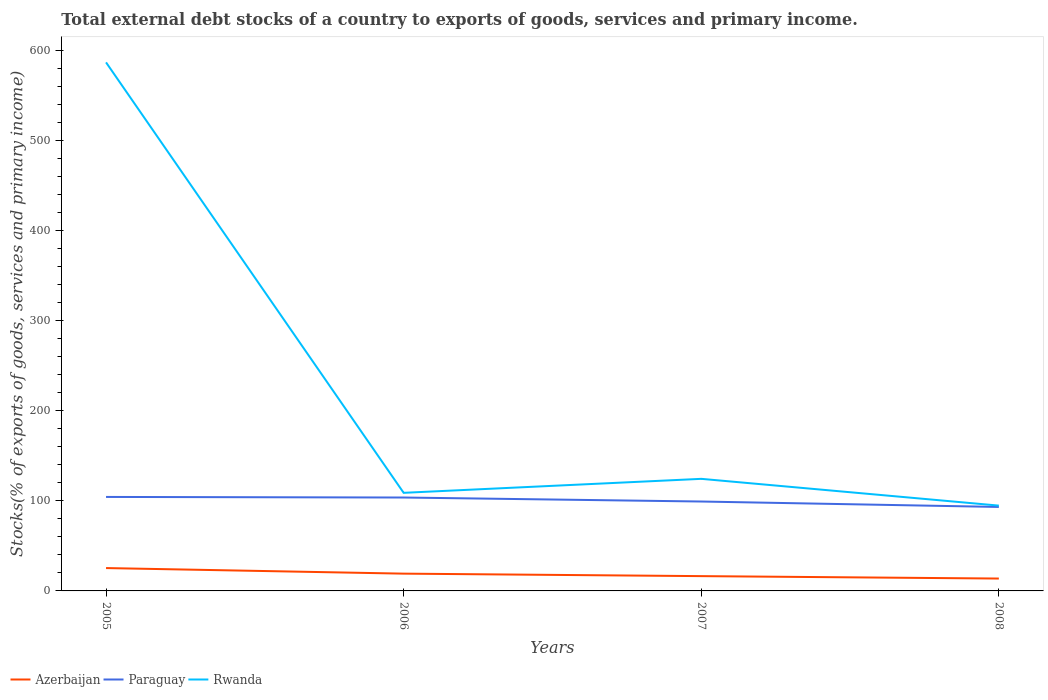Across all years, what is the maximum total debt stocks in Paraguay?
Your response must be concise. 93.31. What is the total total debt stocks in Rwanda in the graph?
Make the answer very short. -15.54. What is the difference between the highest and the second highest total debt stocks in Azerbaijan?
Provide a short and direct response. 11.65. What is the difference between the highest and the lowest total debt stocks in Rwanda?
Offer a terse response. 1. How many lines are there?
Provide a succinct answer. 3. How many years are there in the graph?
Your answer should be compact. 4. Are the values on the major ticks of Y-axis written in scientific E-notation?
Your answer should be compact. No. Does the graph contain any zero values?
Your answer should be very brief. No. Where does the legend appear in the graph?
Provide a succinct answer. Bottom left. What is the title of the graph?
Ensure brevity in your answer.  Total external debt stocks of a country to exports of goods, services and primary income. Does "Mexico" appear as one of the legend labels in the graph?
Give a very brief answer. No. What is the label or title of the X-axis?
Provide a short and direct response. Years. What is the label or title of the Y-axis?
Keep it short and to the point. Stocks(% of exports of goods, services and primary income). What is the Stocks(% of exports of goods, services and primary income) of Azerbaijan in 2005?
Ensure brevity in your answer.  25.39. What is the Stocks(% of exports of goods, services and primary income) of Paraguay in 2005?
Provide a short and direct response. 104.44. What is the Stocks(% of exports of goods, services and primary income) in Rwanda in 2005?
Your answer should be very brief. 587.32. What is the Stocks(% of exports of goods, services and primary income) of Azerbaijan in 2006?
Ensure brevity in your answer.  19.2. What is the Stocks(% of exports of goods, services and primary income) of Paraguay in 2006?
Offer a very short reply. 103.8. What is the Stocks(% of exports of goods, services and primary income) in Rwanda in 2006?
Ensure brevity in your answer.  109.01. What is the Stocks(% of exports of goods, services and primary income) of Azerbaijan in 2007?
Your answer should be very brief. 16.44. What is the Stocks(% of exports of goods, services and primary income) of Paraguay in 2007?
Ensure brevity in your answer.  99.35. What is the Stocks(% of exports of goods, services and primary income) of Rwanda in 2007?
Offer a terse response. 124.55. What is the Stocks(% of exports of goods, services and primary income) of Azerbaijan in 2008?
Ensure brevity in your answer.  13.75. What is the Stocks(% of exports of goods, services and primary income) in Paraguay in 2008?
Provide a short and direct response. 93.31. What is the Stocks(% of exports of goods, services and primary income) in Rwanda in 2008?
Offer a very short reply. 94.79. Across all years, what is the maximum Stocks(% of exports of goods, services and primary income) in Azerbaijan?
Your response must be concise. 25.39. Across all years, what is the maximum Stocks(% of exports of goods, services and primary income) of Paraguay?
Offer a terse response. 104.44. Across all years, what is the maximum Stocks(% of exports of goods, services and primary income) of Rwanda?
Your answer should be compact. 587.32. Across all years, what is the minimum Stocks(% of exports of goods, services and primary income) of Azerbaijan?
Your answer should be compact. 13.75. Across all years, what is the minimum Stocks(% of exports of goods, services and primary income) of Paraguay?
Give a very brief answer. 93.31. Across all years, what is the minimum Stocks(% of exports of goods, services and primary income) in Rwanda?
Provide a short and direct response. 94.79. What is the total Stocks(% of exports of goods, services and primary income) in Azerbaijan in the graph?
Your answer should be compact. 74.78. What is the total Stocks(% of exports of goods, services and primary income) of Paraguay in the graph?
Provide a succinct answer. 400.89. What is the total Stocks(% of exports of goods, services and primary income) in Rwanda in the graph?
Offer a very short reply. 915.67. What is the difference between the Stocks(% of exports of goods, services and primary income) of Azerbaijan in 2005 and that in 2006?
Give a very brief answer. 6.19. What is the difference between the Stocks(% of exports of goods, services and primary income) in Paraguay in 2005 and that in 2006?
Provide a short and direct response. 0.64. What is the difference between the Stocks(% of exports of goods, services and primary income) of Rwanda in 2005 and that in 2006?
Offer a terse response. 478.31. What is the difference between the Stocks(% of exports of goods, services and primary income) in Azerbaijan in 2005 and that in 2007?
Provide a short and direct response. 8.96. What is the difference between the Stocks(% of exports of goods, services and primary income) of Paraguay in 2005 and that in 2007?
Provide a succinct answer. 5.09. What is the difference between the Stocks(% of exports of goods, services and primary income) in Rwanda in 2005 and that in 2007?
Offer a terse response. 462.77. What is the difference between the Stocks(% of exports of goods, services and primary income) of Azerbaijan in 2005 and that in 2008?
Provide a short and direct response. 11.65. What is the difference between the Stocks(% of exports of goods, services and primary income) in Paraguay in 2005 and that in 2008?
Give a very brief answer. 11.13. What is the difference between the Stocks(% of exports of goods, services and primary income) of Rwanda in 2005 and that in 2008?
Offer a very short reply. 492.53. What is the difference between the Stocks(% of exports of goods, services and primary income) of Azerbaijan in 2006 and that in 2007?
Offer a terse response. 2.77. What is the difference between the Stocks(% of exports of goods, services and primary income) in Paraguay in 2006 and that in 2007?
Your response must be concise. 4.45. What is the difference between the Stocks(% of exports of goods, services and primary income) in Rwanda in 2006 and that in 2007?
Ensure brevity in your answer.  -15.54. What is the difference between the Stocks(% of exports of goods, services and primary income) of Azerbaijan in 2006 and that in 2008?
Provide a succinct answer. 5.46. What is the difference between the Stocks(% of exports of goods, services and primary income) in Paraguay in 2006 and that in 2008?
Offer a very short reply. 10.49. What is the difference between the Stocks(% of exports of goods, services and primary income) of Rwanda in 2006 and that in 2008?
Provide a short and direct response. 14.21. What is the difference between the Stocks(% of exports of goods, services and primary income) in Azerbaijan in 2007 and that in 2008?
Ensure brevity in your answer.  2.69. What is the difference between the Stocks(% of exports of goods, services and primary income) of Paraguay in 2007 and that in 2008?
Offer a terse response. 6.04. What is the difference between the Stocks(% of exports of goods, services and primary income) in Rwanda in 2007 and that in 2008?
Keep it short and to the point. 29.75. What is the difference between the Stocks(% of exports of goods, services and primary income) of Azerbaijan in 2005 and the Stocks(% of exports of goods, services and primary income) of Paraguay in 2006?
Your answer should be compact. -78.41. What is the difference between the Stocks(% of exports of goods, services and primary income) in Azerbaijan in 2005 and the Stocks(% of exports of goods, services and primary income) in Rwanda in 2006?
Offer a very short reply. -83.61. What is the difference between the Stocks(% of exports of goods, services and primary income) in Paraguay in 2005 and the Stocks(% of exports of goods, services and primary income) in Rwanda in 2006?
Ensure brevity in your answer.  -4.57. What is the difference between the Stocks(% of exports of goods, services and primary income) in Azerbaijan in 2005 and the Stocks(% of exports of goods, services and primary income) in Paraguay in 2007?
Your response must be concise. -73.95. What is the difference between the Stocks(% of exports of goods, services and primary income) in Azerbaijan in 2005 and the Stocks(% of exports of goods, services and primary income) in Rwanda in 2007?
Ensure brevity in your answer.  -99.15. What is the difference between the Stocks(% of exports of goods, services and primary income) of Paraguay in 2005 and the Stocks(% of exports of goods, services and primary income) of Rwanda in 2007?
Your answer should be very brief. -20.11. What is the difference between the Stocks(% of exports of goods, services and primary income) in Azerbaijan in 2005 and the Stocks(% of exports of goods, services and primary income) in Paraguay in 2008?
Offer a very short reply. -67.91. What is the difference between the Stocks(% of exports of goods, services and primary income) of Azerbaijan in 2005 and the Stocks(% of exports of goods, services and primary income) of Rwanda in 2008?
Ensure brevity in your answer.  -69.4. What is the difference between the Stocks(% of exports of goods, services and primary income) in Paraguay in 2005 and the Stocks(% of exports of goods, services and primary income) in Rwanda in 2008?
Your response must be concise. 9.65. What is the difference between the Stocks(% of exports of goods, services and primary income) in Azerbaijan in 2006 and the Stocks(% of exports of goods, services and primary income) in Paraguay in 2007?
Keep it short and to the point. -80.14. What is the difference between the Stocks(% of exports of goods, services and primary income) of Azerbaijan in 2006 and the Stocks(% of exports of goods, services and primary income) of Rwanda in 2007?
Your answer should be very brief. -105.34. What is the difference between the Stocks(% of exports of goods, services and primary income) of Paraguay in 2006 and the Stocks(% of exports of goods, services and primary income) of Rwanda in 2007?
Give a very brief answer. -20.75. What is the difference between the Stocks(% of exports of goods, services and primary income) of Azerbaijan in 2006 and the Stocks(% of exports of goods, services and primary income) of Paraguay in 2008?
Your answer should be very brief. -74.1. What is the difference between the Stocks(% of exports of goods, services and primary income) of Azerbaijan in 2006 and the Stocks(% of exports of goods, services and primary income) of Rwanda in 2008?
Keep it short and to the point. -75.59. What is the difference between the Stocks(% of exports of goods, services and primary income) of Paraguay in 2006 and the Stocks(% of exports of goods, services and primary income) of Rwanda in 2008?
Provide a succinct answer. 9.01. What is the difference between the Stocks(% of exports of goods, services and primary income) in Azerbaijan in 2007 and the Stocks(% of exports of goods, services and primary income) in Paraguay in 2008?
Make the answer very short. -76.87. What is the difference between the Stocks(% of exports of goods, services and primary income) of Azerbaijan in 2007 and the Stocks(% of exports of goods, services and primary income) of Rwanda in 2008?
Your answer should be compact. -78.36. What is the difference between the Stocks(% of exports of goods, services and primary income) in Paraguay in 2007 and the Stocks(% of exports of goods, services and primary income) in Rwanda in 2008?
Your response must be concise. 4.55. What is the average Stocks(% of exports of goods, services and primary income) of Azerbaijan per year?
Ensure brevity in your answer.  18.7. What is the average Stocks(% of exports of goods, services and primary income) in Paraguay per year?
Your answer should be very brief. 100.22. What is the average Stocks(% of exports of goods, services and primary income) in Rwanda per year?
Give a very brief answer. 228.92. In the year 2005, what is the difference between the Stocks(% of exports of goods, services and primary income) of Azerbaijan and Stocks(% of exports of goods, services and primary income) of Paraguay?
Provide a short and direct response. -79.04. In the year 2005, what is the difference between the Stocks(% of exports of goods, services and primary income) of Azerbaijan and Stocks(% of exports of goods, services and primary income) of Rwanda?
Keep it short and to the point. -561.92. In the year 2005, what is the difference between the Stocks(% of exports of goods, services and primary income) of Paraguay and Stocks(% of exports of goods, services and primary income) of Rwanda?
Offer a terse response. -482.88. In the year 2006, what is the difference between the Stocks(% of exports of goods, services and primary income) in Azerbaijan and Stocks(% of exports of goods, services and primary income) in Paraguay?
Your answer should be compact. -84.6. In the year 2006, what is the difference between the Stocks(% of exports of goods, services and primary income) in Azerbaijan and Stocks(% of exports of goods, services and primary income) in Rwanda?
Your answer should be compact. -89.8. In the year 2006, what is the difference between the Stocks(% of exports of goods, services and primary income) in Paraguay and Stocks(% of exports of goods, services and primary income) in Rwanda?
Your response must be concise. -5.21. In the year 2007, what is the difference between the Stocks(% of exports of goods, services and primary income) of Azerbaijan and Stocks(% of exports of goods, services and primary income) of Paraguay?
Provide a short and direct response. -82.91. In the year 2007, what is the difference between the Stocks(% of exports of goods, services and primary income) of Azerbaijan and Stocks(% of exports of goods, services and primary income) of Rwanda?
Your answer should be compact. -108.11. In the year 2007, what is the difference between the Stocks(% of exports of goods, services and primary income) in Paraguay and Stocks(% of exports of goods, services and primary income) in Rwanda?
Offer a terse response. -25.2. In the year 2008, what is the difference between the Stocks(% of exports of goods, services and primary income) of Azerbaijan and Stocks(% of exports of goods, services and primary income) of Paraguay?
Ensure brevity in your answer.  -79.56. In the year 2008, what is the difference between the Stocks(% of exports of goods, services and primary income) of Azerbaijan and Stocks(% of exports of goods, services and primary income) of Rwanda?
Provide a succinct answer. -81.05. In the year 2008, what is the difference between the Stocks(% of exports of goods, services and primary income) in Paraguay and Stocks(% of exports of goods, services and primary income) in Rwanda?
Provide a succinct answer. -1.49. What is the ratio of the Stocks(% of exports of goods, services and primary income) in Azerbaijan in 2005 to that in 2006?
Your answer should be very brief. 1.32. What is the ratio of the Stocks(% of exports of goods, services and primary income) of Paraguay in 2005 to that in 2006?
Your response must be concise. 1.01. What is the ratio of the Stocks(% of exports of goods, services and primary income) of Rwanda in 2005 to that in 2006?
Ensure brevity in your answer.  5.39. What is the ratio of the Stocks(% of exports of goods, services and primary income) in Azerbaijan in 2005 to that in 2007?
Your answer should be very brief. 1.54. What is the ratio of the Stocks(% of exports of goods, services and primary income) in Paraguay in 2005 to that in 2007?
Offer a terse response. 1.05. What is the ratio of the Stocks(% of exports of goods, services and primary income) in Rwanda in 2005 to that in 2007?
Your response must be concise. 4.72. What is the ratio of the Stocks(% of exports of goods, services and primary income) in Azerbaijan in 2005 to that in 2008?
Keep it short and to the point. 1.85. What is the ratio of the Stocks(% of exports of goods, services and primary income) in Paraguay in 2005 to that in 2008?
Offer a terse response. 1.12. What is the ratio of the Stocks(% of exports of goods, services and primary income) of Rwanda in 2005 to that in 2008?
Keep it short and to the point. 6.2. What is the ratio of the Stocks(% of exports of goods, services and primary income) in Azerbaijan in 2006 to that in 2007?
Your response must be concise. 1.17. What is the ratio of the Stocks(% of exports of goods, services and primary income) of Paraguay in 2006 to that in 2007?
Offer a very short reply. 1.04. What is the ratio of the Stocks(% of exports of goods, services and primary income) in Rwanda in 2006 to that in 2007?
Ensure brevity in your answer.  0.88. What is the ratio of the Stocks(% of exports of goods, services and primary income) in Azerbaijan in 2006 to that in 2008?
Make the answer very short. 1.4. What is the ratio of the Stocks(% of exports of goods, services and primary income) in Paraguay in 2006 to that in 2008?
Offer a very short reply. 1.11. What is the ratio of the Stocks(% of exports of goods, services and primary income) in Rwanda in 2006 to that in 2008?
Your response must be concise. 1.15. What is the ratio of the Stocks(% of exports of goods, services and primary income) in Azerbaijan in 2007 to that in 2008?
Ensure brevity in your answer.  1.2. What is the ratio of the Stocks(% of exports of goods, services and primary income) of Paraguay in 2007 to that in 2008?
Keep it short and to the point. 1.06. What is the ratio of the Stocks(% of exports of goods, services and primary income) in Rwanda in 2007 to that in 2008?
Offer a very short reply. 1.31. What is the difference between the highest and the second highest Stocks(% of exports of goods, services and primary income) in Azerbaijan?
Your answer should be very brief. 6.19. What is the difference between the highest and the second highest Stocks(% of exports of goods, services and primary income) of Paraguay?
Ensure brevity in your answer.  0.64. What is the difference between the highest and the second highest Stocks(% of exports of goods, services and primary income) in Rwanda?
Provide a short and direct response. 462.77. What is the difference between the highest and the lowest Stocks(% of exports of goods, services and primary income) in Azerbaijan?
Offer a terse response. 11.65. What is the difference between the highest and the lowest Stocks(% of exports of goods, services and primary income) in Paraguay?
Your answer should be very brief. 11.13. What is the difference between the highest and the lowest Stocks(% of exports of goods, services and primary income) of Rwanda?
Make the answer very short. 492.53. 